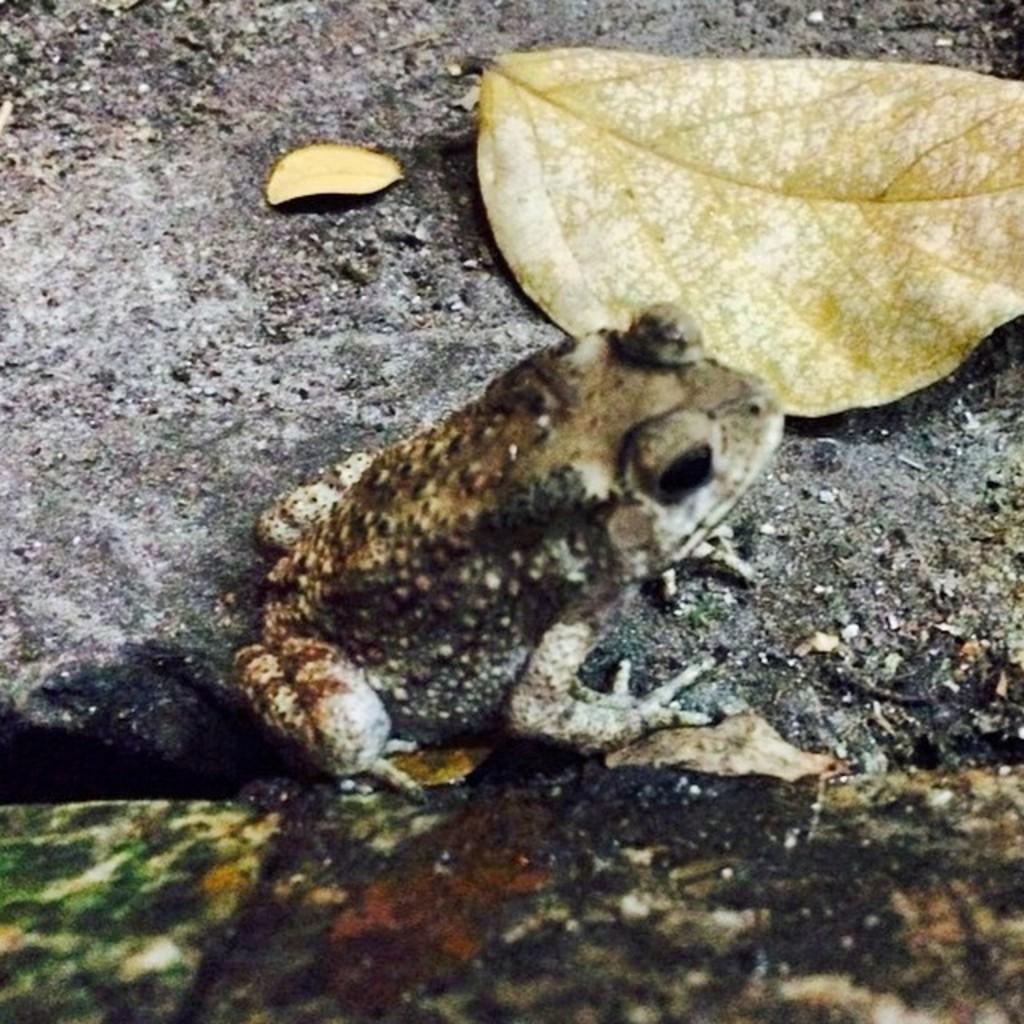Could you give a brief overview of what you see in this image? In this picture there is a frog and there is a dried leaf beside it. 